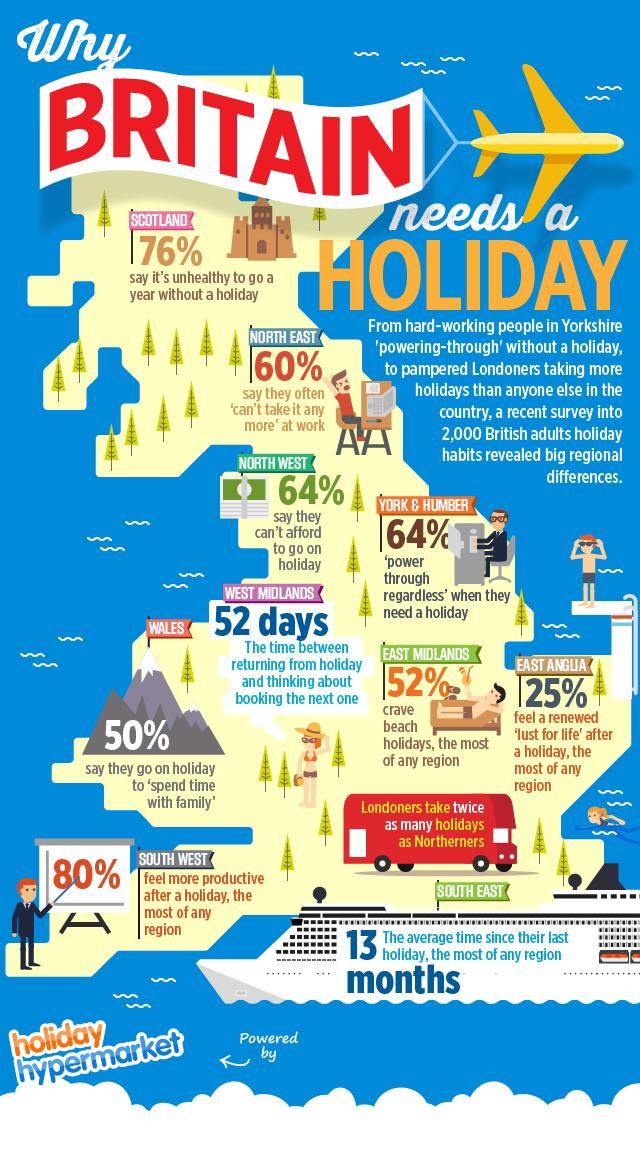Specify some key components in this picture. According to the data, 52% of individuals prefer to spend their vacations at the beach. The region that desires beach holidays the most is the East Midlands. The color of the aeroplane is yellow. If a Northerner takes an average of 2 holidays per year, then a Londoner would take an average of 4 holidays per year. Approximately two months after returning from a holiday, the West Midlands plan their next one. In North West, approximately 36% of households can afford to go on a holiday. 